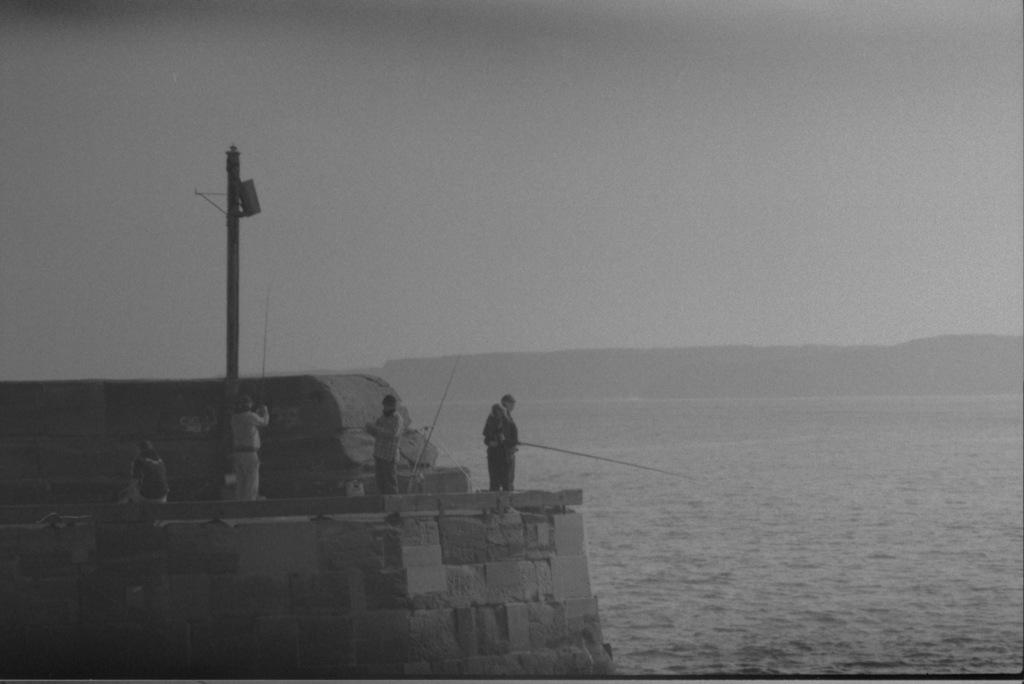Who or what can be seen in the image? There are people in the image. What is the background of the image? There is a wall and the sky visible in the background of the image. What is the water feature in the image? There is water visible in the image. What is the pole used for in the image? The purpose of the pole is not specified, but it is present in the image. What type of pet can be seen playing with the edge of the water in the image? There is no pet present in the image, and the edge of the water is not depicted as a play area for any animals. 